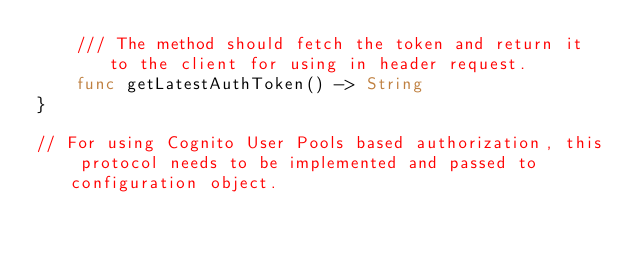Convert code to text. <code><loc_0><loc_0><loc_500><loc_500><_Swift_>    /// The method should fetch the token and return it to the client for using in header request.
    func getLatestAuthToken() -> String
}

// For using Cognito User Pools based authorization, this protocol needs to be implemented and passed to configuration object.</code> 